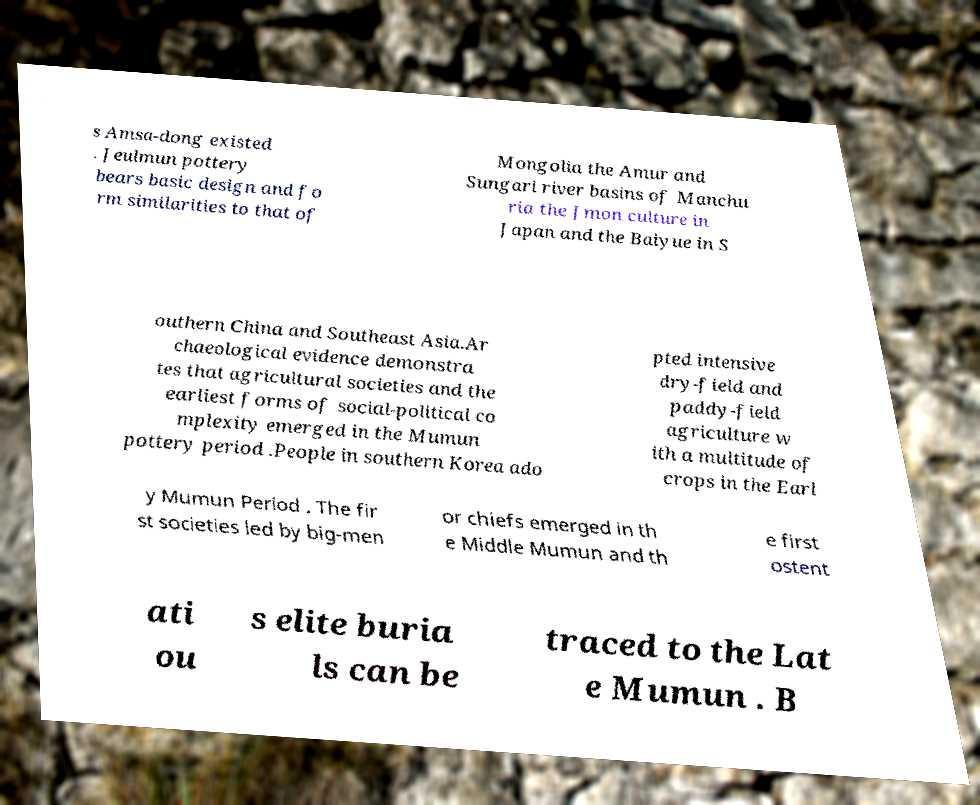I need the written content from this picture converted into text. Can you do that? s Amsa-dong existed . Jeulmun pottery bears basic design and fo rm similarities to that of Mongolia the Amur and Sungari river basins of Manchu ria the Jmon culture in Japan and the Baiyue in S outhern China and Southeast Asia.Ar chaeological evidence demonstra tes that agricultural societies and the earliest forms of social-political co mplexity emerged in the Mumun pottery period .People in southern Korea ado pted intensive dry-field and paddy-field agriculture w ith a multitude of crops in the Earl y Mumun Period . The fir st societies led by big-men or chiefs emerged in th e Middle Mumun and th e first ostent ati ou s elite buria ls can be traced to the Lat e Mumun . B 